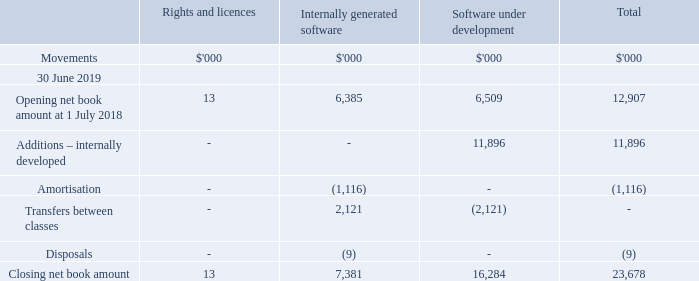11 Intangible assets
(a) Intangible assets
RIGHTS AND LICENCES
Certain licences that NEXTDC possesses have an indefinite useful life and are carried at cost less impairment losses and are subject to impairment review at least annually and whenever there is an indication that it may be impaired.
Other licences that NEXTDC acquires are carried at cost less accumulated amortisation and accumulated impairment losses. Amortisation is recognised on a straight-line basis over the estimated useful life. The estimated useful life and amortisation method are reviewed at the end of each annual reporting period.
INTERNALLY GENERATED SOFTWARE
Internally developed software is capitalised at cost less accumulated amortisation. Amortisation is calculated using the straight-line basis over the asset’s useful economic life which is generally two to three years. Their useful lives and potential impairment are reviewed at the end of each financial year.
SOFTWARE UNDER DEVELOPMENT
Costs incurred in developing products or systems and costs incurred in acquiring software and licenses that will contribute to future period financial benefits through revenue generation and/or cost reduction are capitalised to software and systems. Costs capitalised include external direct costs of materials and services and employee costs.
Assets in the course of construction include only those costs directly attributable to the development phase and are only recognised following completion of technical feasibility and where the Group has an intention and ability to use the asset.
What were the 3 types of intangible assets? Rights and licences, internally generated software, software under development. What was the total opening net book amount at 1 July 2018?
Answer scale should be: thousand. 12,907. What was the total closing net book account at 30 June 2019?
Answer scale should be: thousand. 23,678. What was the difference between total opening and closing net book amount?
Answer scale should be: thousand. 23,678 - 12,907 
Answer: 10771. What was the change in net book amount for software under development between 2018 and 2019?
Answer scale should be: thousand. 16,284 - 6,509 
Answer: 9775. What percentage of the total gain in book amount was due to internally generated software?
Answer scale should be: percent. (7,381 - 6,385) / (23,678 - 12,907) 
Answer: 9.25. 